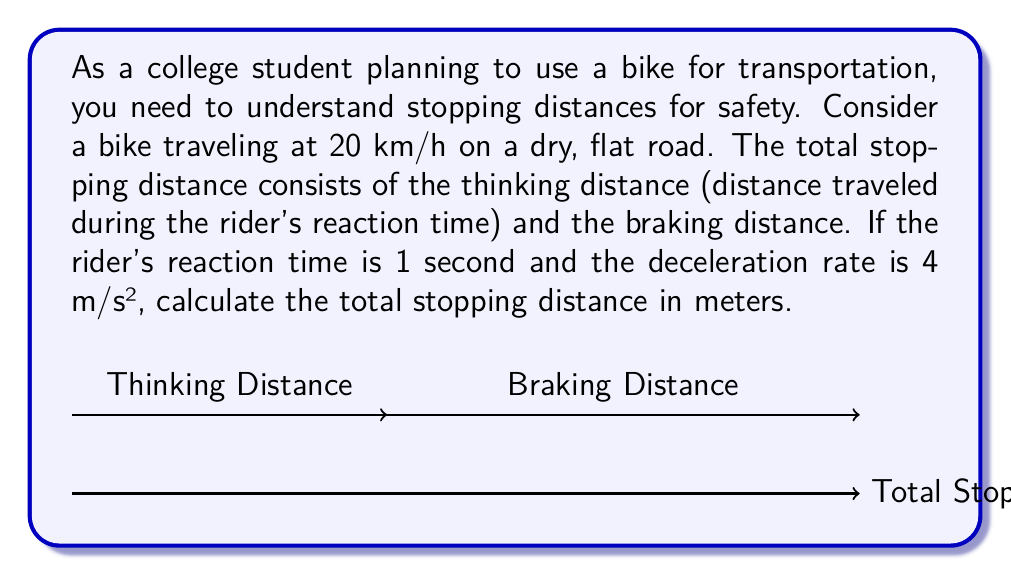Teach me how to tackle this problem. Let's break this down step-by-step:

1) First, we need to convert the speed from km/h to m/s:
   $20 \text{ km/h} = 20 \times \frac{1000 \text{ m}}{3600 \text{ s}} = \frac{50}{9} \text{ m/s} \approx 5.56 \text{ m/s}$

2) Thinking distance:
   $d_t = v \times t$, where $v$ is velocity and $t$ is reaction time
   $d_t = 5.56 \text{ m/s} \times 1 \text{ s} = 5.56 \text{ m}$

3) For the braking distance, we use the equation:
   $d_b = \frac{v^2}{2a}$, where $a$ is the deceleration rate
   $d_b = \frac{(5.56 \text{ m/s})^2}{2 \times 4 \text{ m/s}^2} = 3.86 \text{ m}$

4) Total stopping distance:
   $d_{\text{total}} = d_t + d_b = 5.56 \text{ m} + 3.86 \text{ m} = 9.42 \text{ m}$

Therefore, the total stopping distance is approximately 9.42 meters.
Answer: 9.42 m 